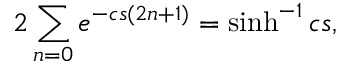<formula> <loc_0><loc_0><loc_500><loc_500>2 \sum _ { n = 0 } e ^ { - c s ( 2 n + 1 ) } = \sinh ^ { - 1 } c s ,</formula> 